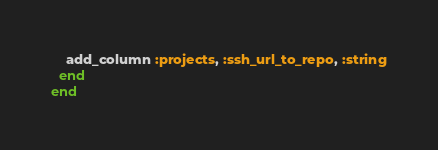Convert code to text. <code><loc_0><loc_0><loc_500><loc_500><_Ruby_>    add_column :projects, :ssh_url_to_repo, :string
  end
end
</code> 